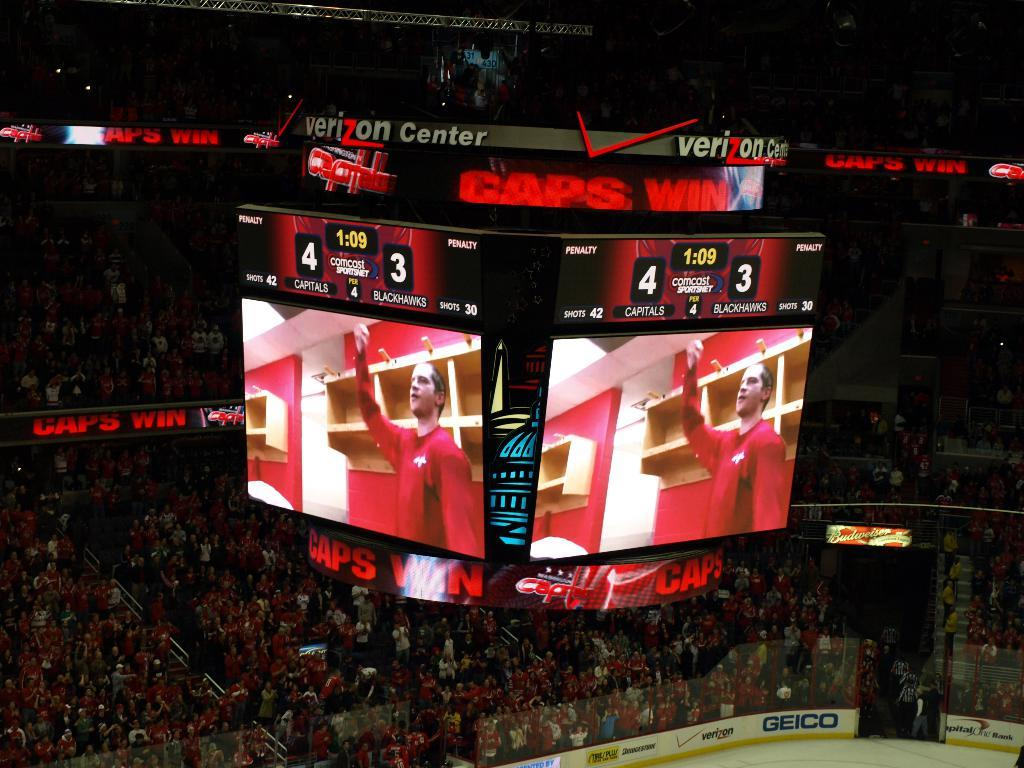<image>
Render a clear and concise summary of the photo. The large display at a sporting event at the Verizon Center. 